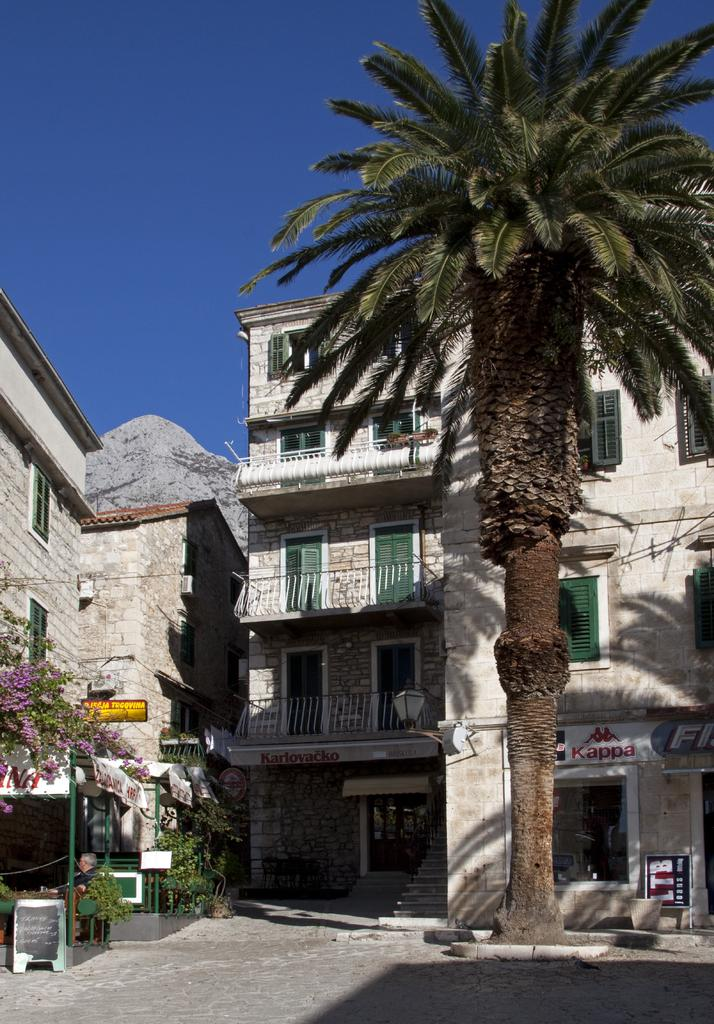<image>
Describe the image concisely. Kappa is printed onto a banner above this cozy looking shop. 